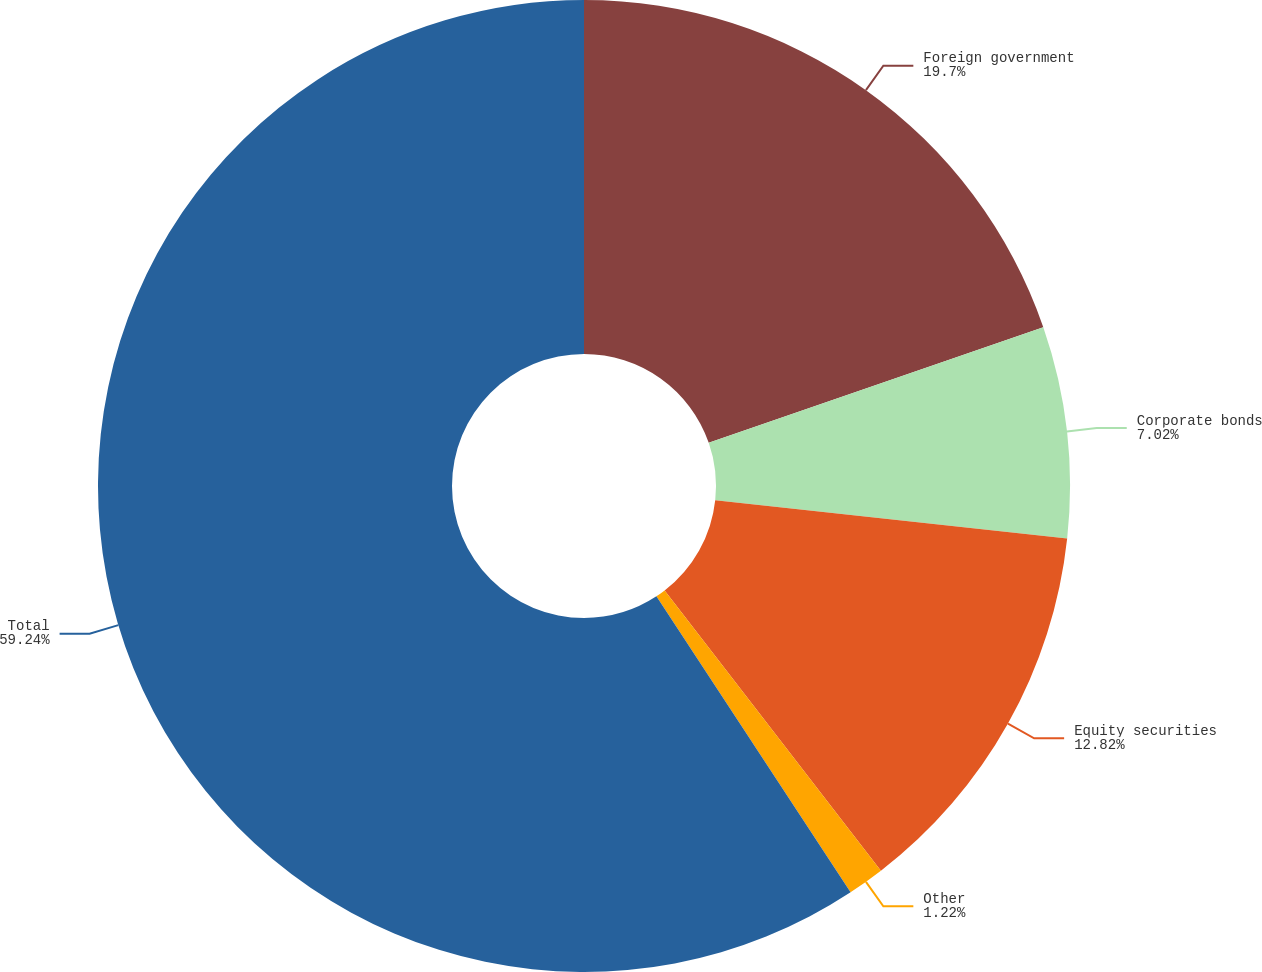Convert chart to OTSL. <chart><loc_0><loc_0><loc_500><loc_500><pie_chart><fcel>Foreign government<fcel>Corporate bonds<fcel>Equity securities<fcel>Other<fcel>Total<nl><fcel>19.7%<fcel>7.02%<fcel>12.82%<fcel>1.22%<fcel>59.24%<nl></chart> 